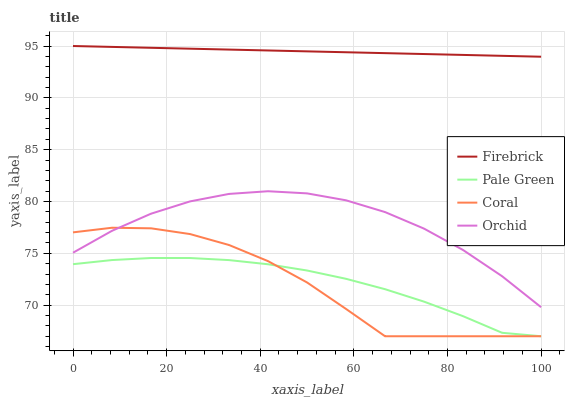Does Pale Green have the minimum area under the curve?
Answer yes or no. No. Does Pale Green have the maximum area under the curve?
Answer yes or no. No. Is Pale Green the smoothest?
Answer yes or no. No. Is Pale Green the roughest?
Answer yes or no. No. Does Orchid have the lowest value?
Answer yes or no. No. Does Coral have the highest value?
Answer yes or no. No. Is Pale Green less than Orchid?
Answer yes or no. Yes. Is Firebrick greater than Orchid?
Answer yes or no. Yes. Does Pale Green intersect Orchid?
Answer yes or no. No. 